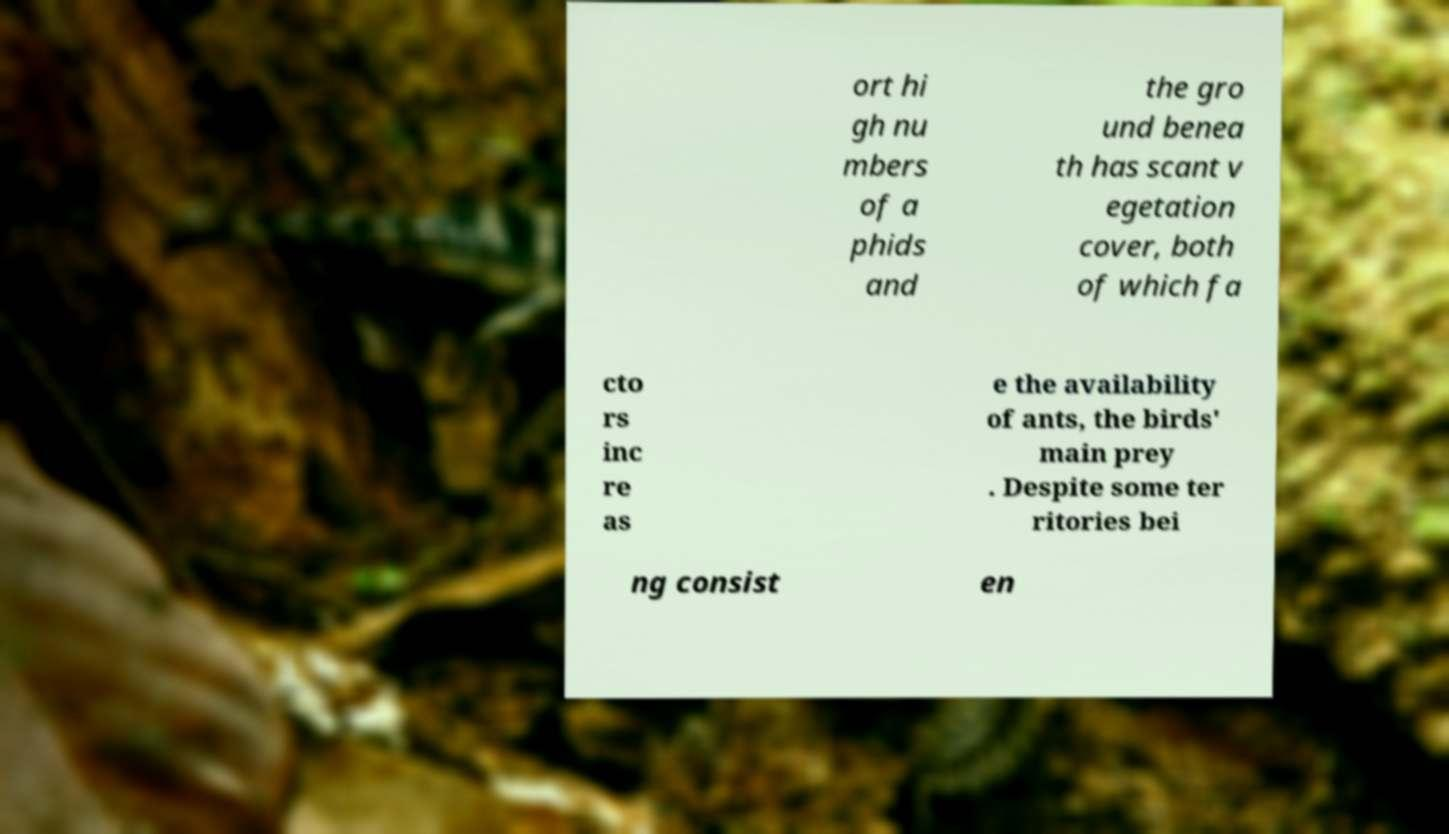Could you extract and type out the text from this image? ort hi gh nu mbers of a phids and the gro und benea th has scant v egetation cover, both of which fa cto rs inc re as e the availability of ants, the birds' main prey . Despite some ter ritories bei ng consist en 